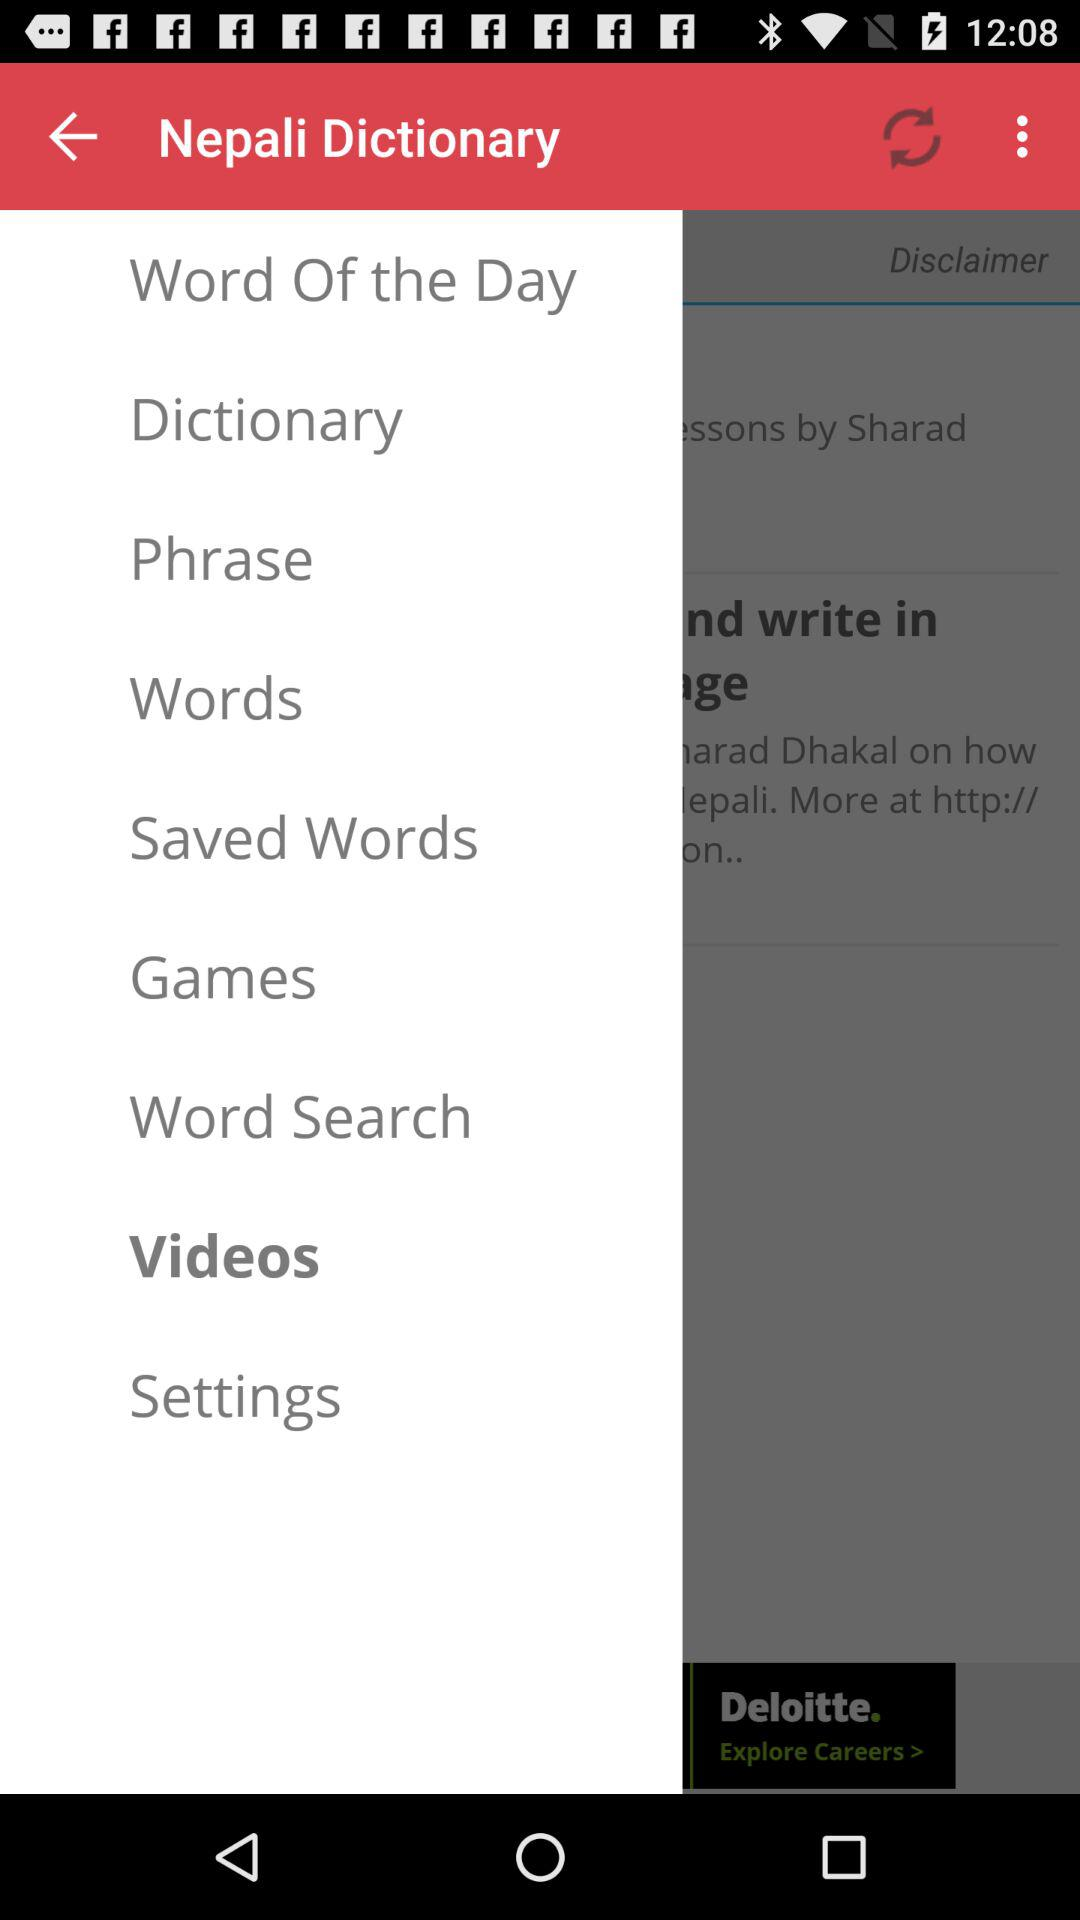What is the app name? The app name is "Nepali Dictionary". 